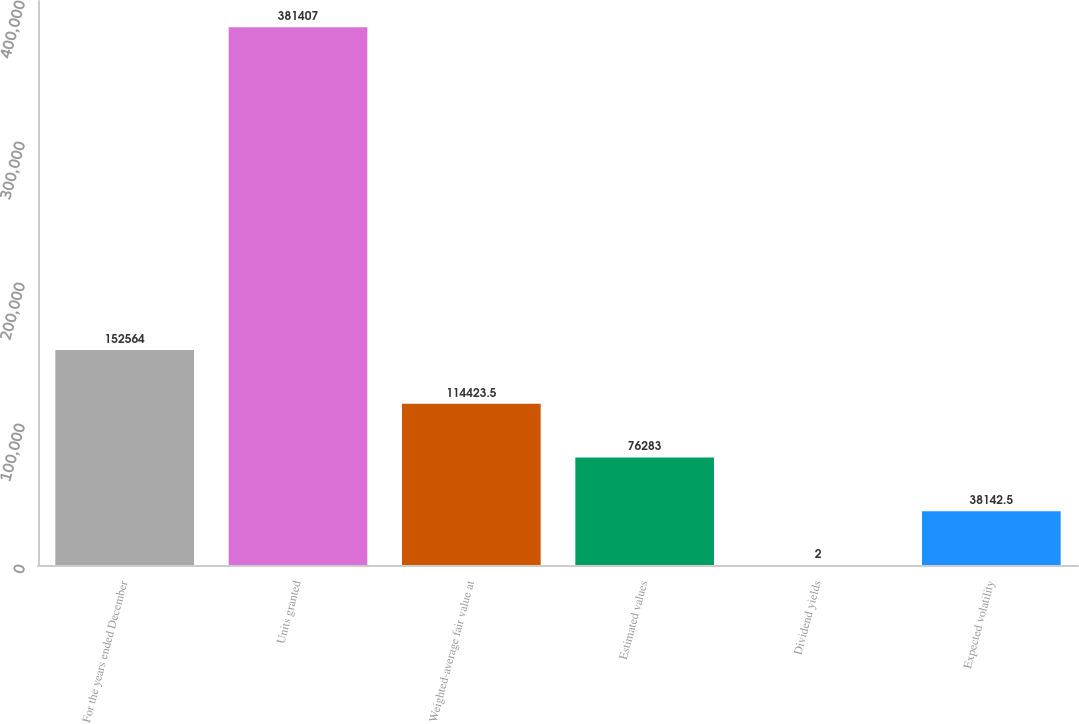Convert chart. <chart><loc_0><loc_0><loc_500><loc_500><bar_chart><fcel>For the years ended December<fcel>Units granted<fcel>Weighted-average fair value at<fcel>Estimated values<fcel>Dividend yields<fcel>Expected volatility<nl><fcel>152564<fcel>381407<fcel>114424<fcel>76283<fcel>2<fcel>38142.5<nl></chart> 